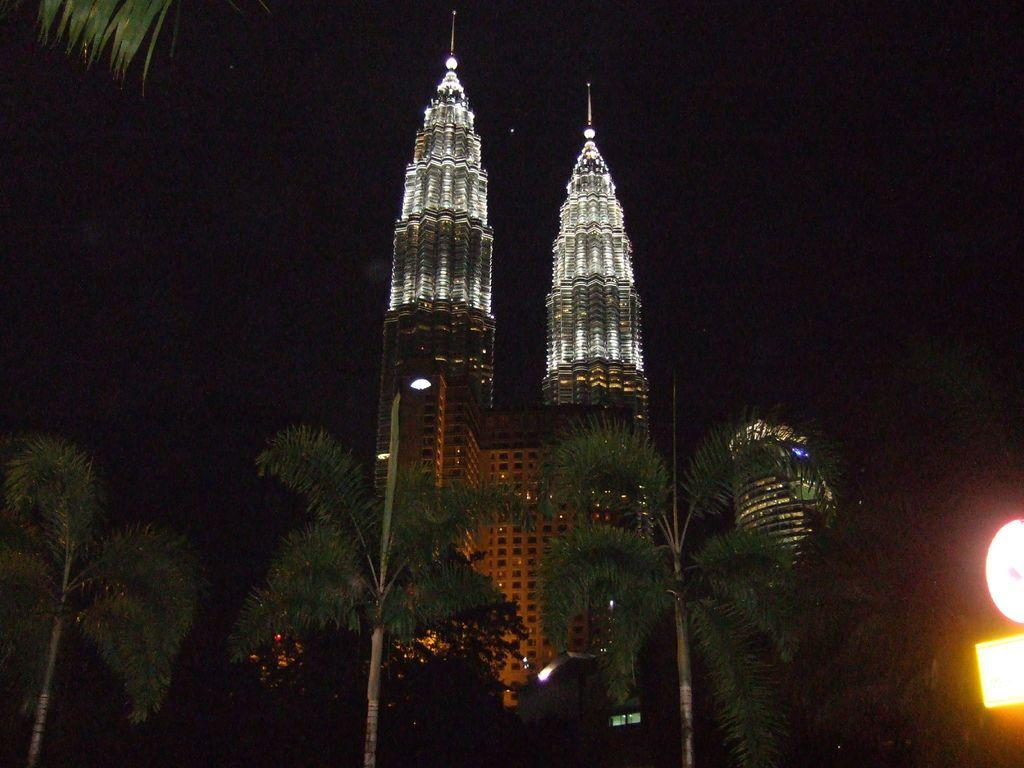What is the primary subject of the image? The primary subject of the image is a building. What is the lighting condition in the image? The image was taken in the dark. What can be seen at the bottom of the image? There are trees at the bottom of the image. Where are the lights located in the image? There are two lights in the bottom right-hand corner of the image. What type of plant is being taxed in the image? There is no plant or tax-related information present in the image. 